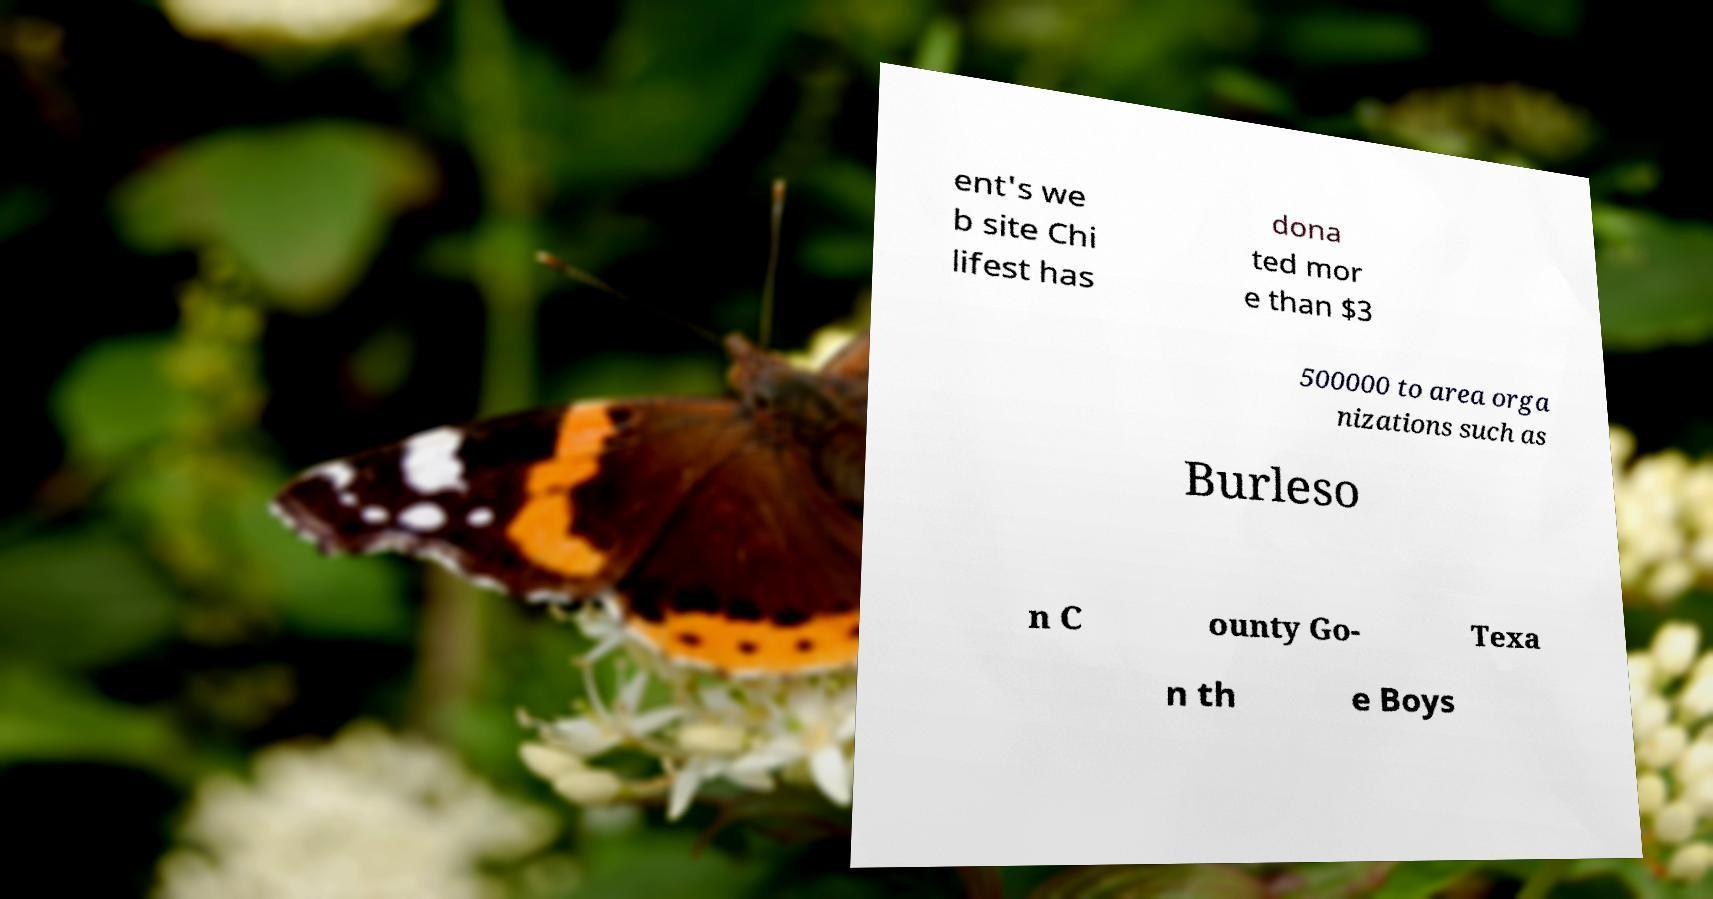Can you read and provide the text displayed in the image?This photo seems to have some interesting text. Can you extract and type it out for me? ent's we b site Chi lifest has dona ted mor e than $3 500000 to area orga nizations such as Burleso n C ounty Go- Texa n th e Boys 